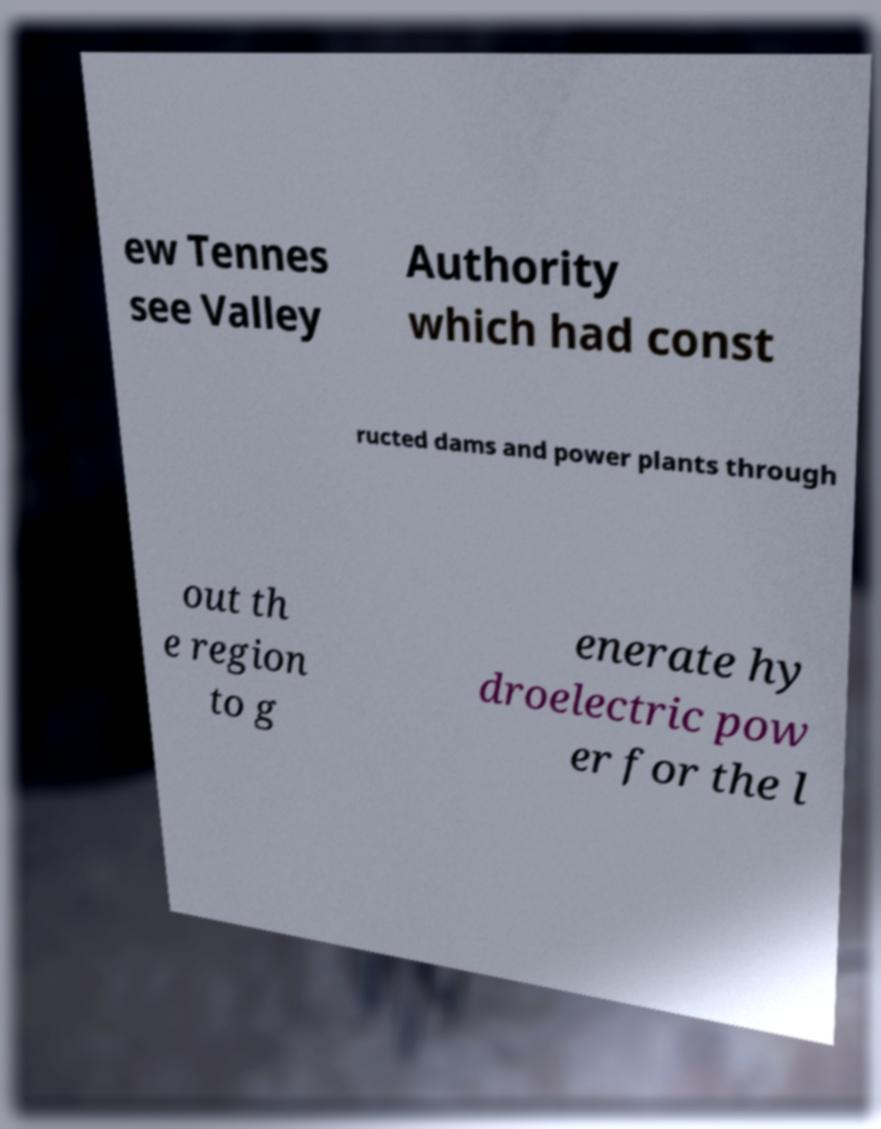Can you accurately transcribe the text from the provided image for me? ew Tennes see Valley Authority which had const ructed dams and power plants through out th e region to g enerate hy droelectric pow er for the l 